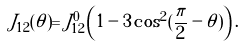<formula> <loc_0><loc_0><loc_500><loc_500>J _ { 1 2 } ( \theta ) = J _ { 1 2 } ^ { 0 } \left ( 1 - 3 \cos ^ { 2 } ( \frac { \pi } { 2 } - \theta ) \right ) .</formula> 